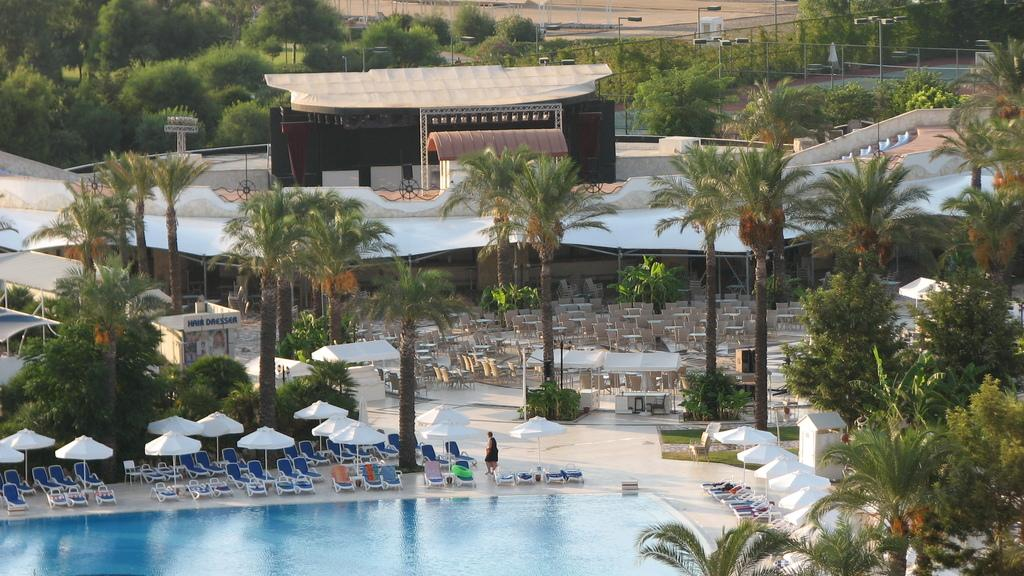What type of vegetation is present in the image? There are trees with green color in the image. What color are the umbrellas in the image? The umbrellas in the image are in white color. What color are the chairs in the image? The chairs in the image are in blue color. What body of water is visible in the image? There is a swimming pool in the image. What structures can be seen in the background of the image? There are light poles in the background of the image. What type of oatmeal is being served during recess in the image? There is no oatmeal or recess present in the image. How does the wilderness affect the trees in the image? There is no wilderness present in the image; it features a manicured outdoor area with chairs, umbrellas, and a swimming pool. 